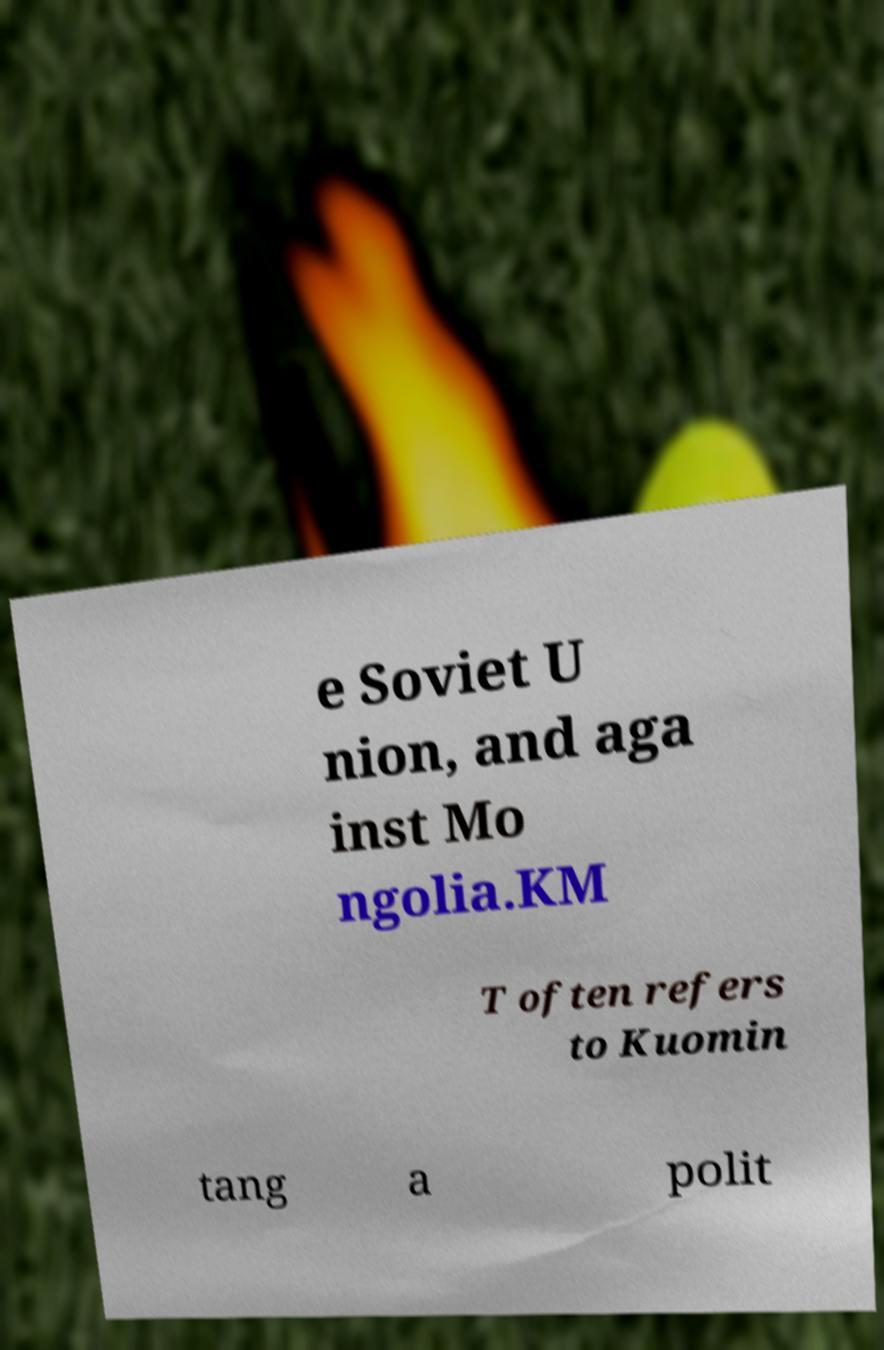Can you accurately transcribe the text from the provided image for me? e Soviet U nion, and aga inst Mo ngolia.KM T often refers to Kuomin tang a polit 